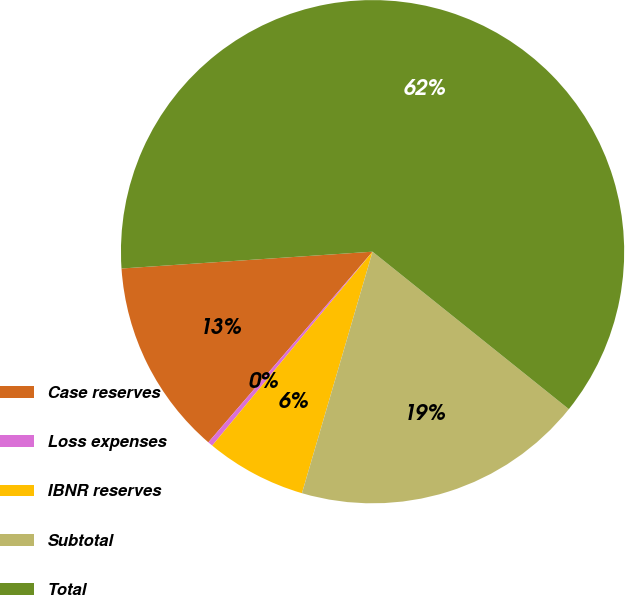Convert chart. <chart><loc_0><loc_0><loc_500><loc_500><pie_chart><fcel>Case reserves<fcel>Loss expenses<fcel>IBNR reserves<fcel>Subtotal<fcel>Total<nl><fcel>12.62%<fcel>0.32%<fcel>6.47%<fcel>18.77%<fcel>61.83%<nl></chart> 